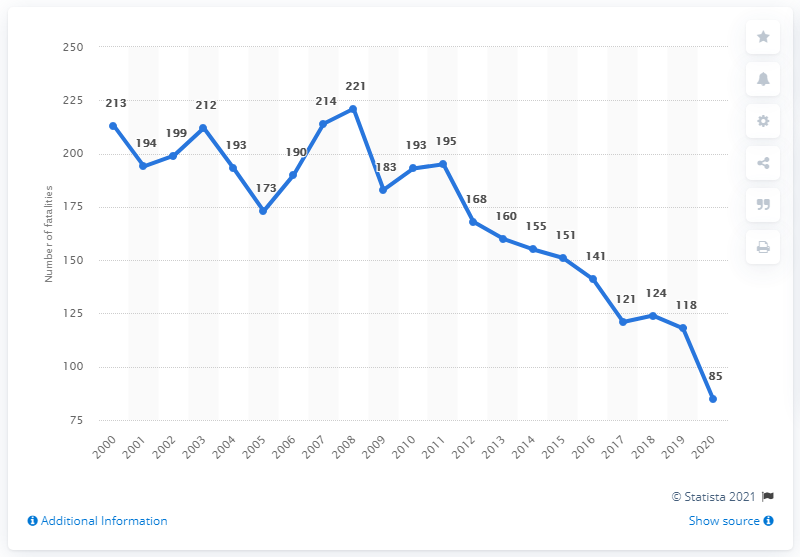List a handful of essential elements in this visual. The peak number of fatalities occurred in 2008. There were 85 fatalities in traffic accidents in Singapore in 2020. The average number of fatalities from 2000 to 2005 was 197.33. 